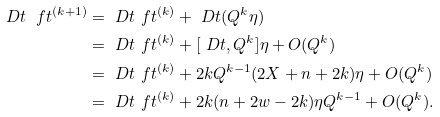Convert formula to latex. <formula><loc_0><loc_0><loc_500><loc_500>\ D t \ f t ^ { ( k + 1 ) } & = \ D t \ f t ^ { ( k ) } + \ D t ( Q ^ { k } \eta ) \\ & = \ D t \ f t ^ { ( k ) } + [ \ D t , Q ^ { k } ] \eta + O ( Q ^ { k } ) \\ & = \ D t \ f t ^ { ( k ) } + 2 k Q ^ { k - 1 } ( 2 X + n + 2 k ) \eta + O ( Q ^ { k } ) \\ & = \ D t \ f t ^ { ( k ) } + 2 k ( n + 2 w - 2 k ) \eta Q ^ { k - 1 } + O ( Q ^ { k } ) .</formula> 